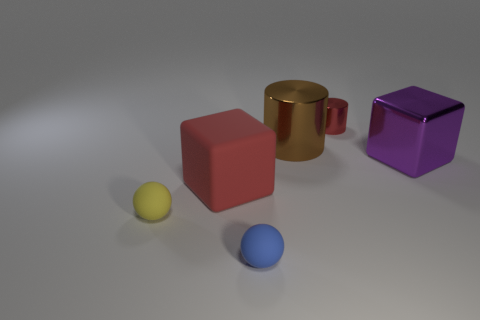What color is the large shiny block?
Your answer should be compact. Purple. How many things are either large purple shiny cubes or objects?
Your response must be concise. 6. Are there fewer purple metallic cubes that are on the right side of the large purple metal block than small blue objects?
Give a very brief answer. Yes. Are there more small shiny cylinders that are on the left side of the big purple metallic thing than things that are left of the small cylinder?
Ensure brevity in your answer.  No. Is there any other thing that has the same color as the big shiny cube?
Ensure brevity in your answer.  No. What material is the tiny object that is behind the purple metal thing?
Provide a short and direct response. Metal. Do the purple thing and the red metallic cylinder have the same size?
Keep it short and to the point. No. What number of other objects are there of the same size as the red metallic cylinder?
Offer a very short reply. 2. Do the matte block and the small shiny cylinder have the same color?
Your answer should be compact. Yes. There is a red thing that is right of the thing in front of the matte ball that is behind the tiny blue rubber thing; what is its shape?
Your answer should be compact. Cylinder. 